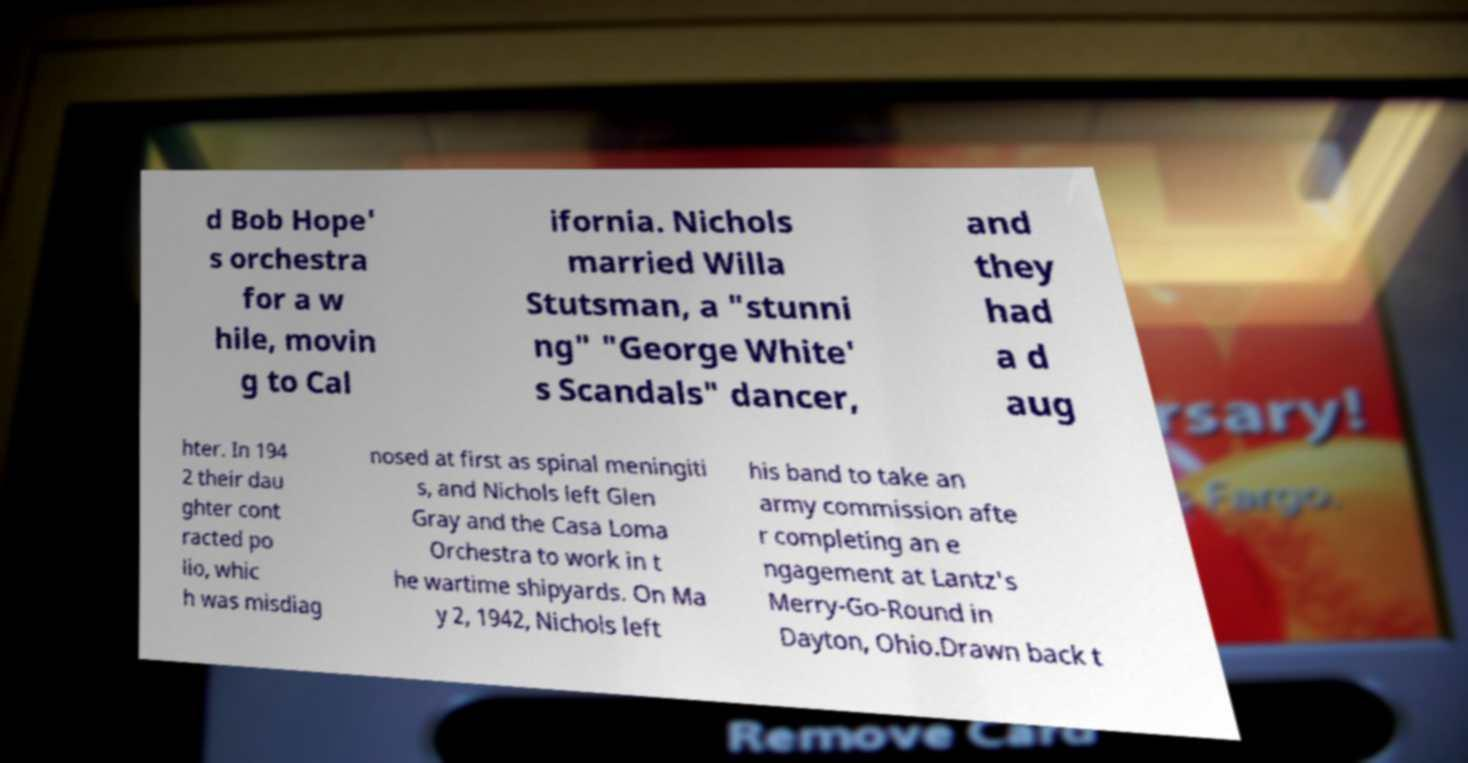Please read and relay the text visible in this image. What does it say? d Bob Hope' s orchestra for a w hile, movin g to Cal ifornia. Nichols married Willa Stutsman, a "stunni ng" "George White' s Scandals" dancer, and they had a d aug hter. In 194 2 their dau ghter cont racted po lio, whic h was misdiag nosed at first as spinal meningiti s, and Nichols left Glen Gray and the Casa Loma Orchestra to work in t he wartime shipyards. On Ma y 2, 1942, Nichols left his band to take an army commission afte r completing an e ngagement at Lantz's Merry-Go-Round in Dayton, Ohio.Drawn back t 